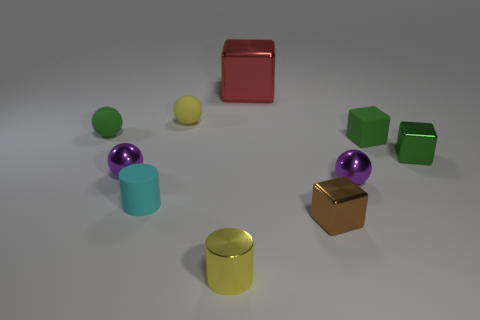Subtract all tiny green matte cubes. How many cubes are left? 3 Subtract all purple spheres. How many spheres are left? 2 Subtract all spheres. How many objects are left? 6 Add 2 purple objects. How many purple objects exist? 4 Subtract 0 blue cylinders. How many objects are left? 10 Subtract 4 balls. How many balls are left? 0 Subtract all red cylinders. Subtract all brown blocks. How many cylinders are left? 2 Subtract all purple cubes. How many blue cylinders are left? 0 Subtract all big metallic blocks. Subtract all small purple things. How many objects are left? 7 Add 6 small purple shiny spheres. How many small purple shiny spheres are left? 8 